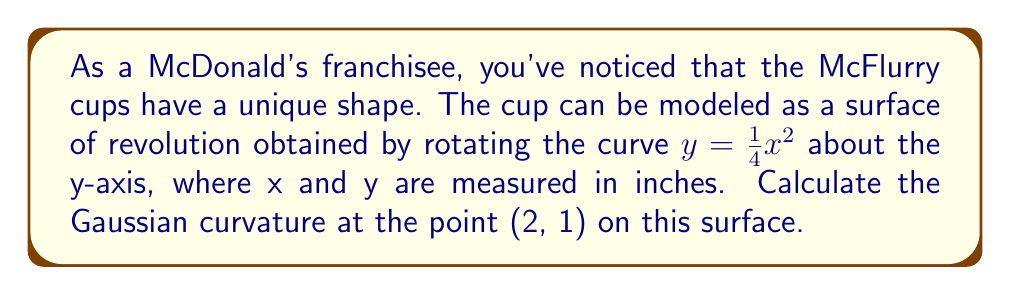Provide a solution to this math problem. Let's approach this step-by-step:

1) For a surface of revolution generated by rotating $y = f(x)$ about the y-axis, the Gaussian curvature K is given by:

   $$K = -\frac{f''(x)}{f(x)[1 + (f'(x))^2]^2}$$

2) In our case, $f(x) = \frac{1}{4}x^2$. Let's calculate $f'(x)$ and $f''(x)$:

   $f'(x) = \frac{1}{2}x$
   $f''(x) = \frac{1}{2}$

3) Now, let's substitute these into our formula:

   $$K = -\frac{\frac{1}{2}}{\frac{1}{4}x^2[1 + (\frac{1}{2}x)^2]^2}$$

4) We need to calculate this at the point (2, 1). Note that x = 2 at this point:

   $$K = -\frac{\frac{1}{2}}{\frac{1}{4}(2)^2[1 + (\frac{1}{2}(2))^2]^2}$$

5) Let's simplify:

   $$K = -\frac{\frac{1}{2}}{1[1 + 1]^2} = -\frac{\frac{1}{2}}{4} = -\frac{1}{8}$$

6) Therefore, the Gaussian curvature at the point (2, 1) is $-\frac{1}{8}$ per square inch.
Answer: $-\frac{1}{8}$ in$^{-2}$ 